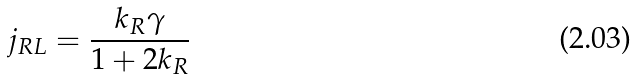<formula> <loc_0><loc_0><loc_500><loc_500>j _ { R L } = \frac { k _ { R } \gamma } { 1 + 2 k _ { R } }</formula> 